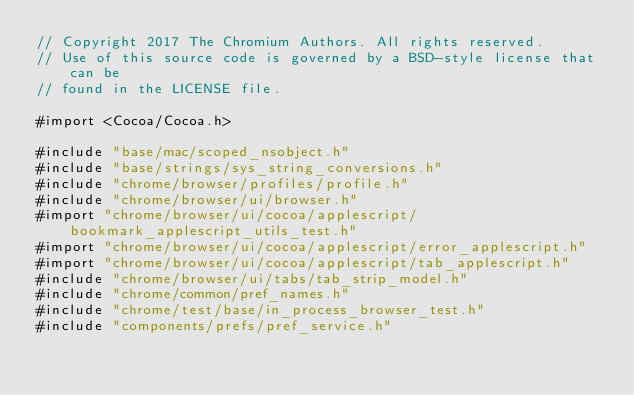Convert code to text. <code><loc_0><loc_0><loc_500><loc_500><_ObjectiveC_>// Copyright 2017 The Chromium Authors. All rights reserved.
// Use of this source code is governed by a BSD-style license that can be
// found in the LICENSE file.

#import <Cocoa/Cocoa.h>

#include "base/mac/scoped_nsobject.h"
#include "base/strings/sys_string_conversions.h"
#include "chrome/browser/profiles/profile.h"
#include "chrome/browser/ui/browser.h"
#import "chrome/browser/ui/cocoa/applescript/bookmark_applescript_utils_test.h"
#import "chrome/browser/ui/cocoa/applescript/error_applescript.h"
#import "chrome/browser/ui/cocoa/applescript/tab_applescript.h"
#include "chrome/browser/ui/tabs/tab_strip_model.h"
#include "chrome/common/pref_names.h"
#include "chrome/test/base/in_process_browser_test.h"
#include "components/prefs/pref_service.h"</code> 